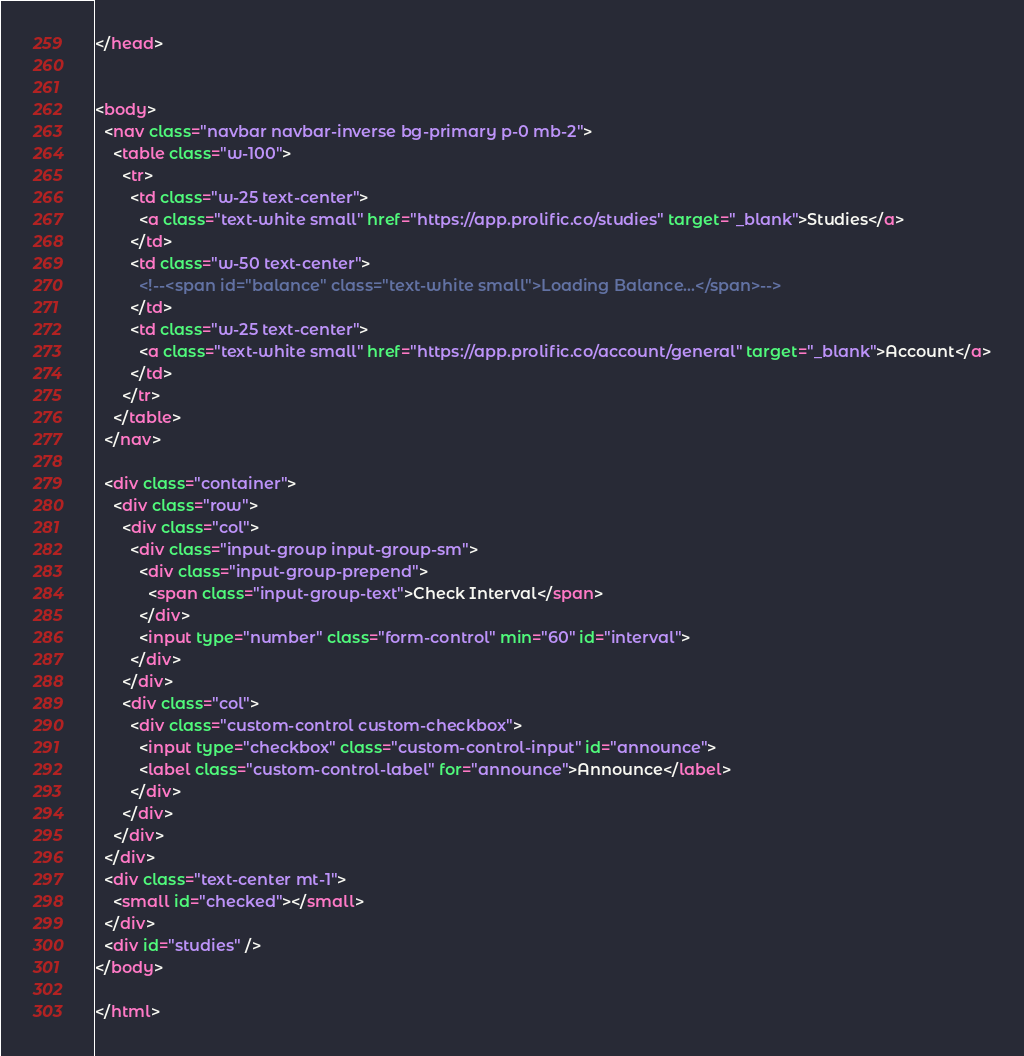<code> <loc_0><loc_0><loc_500><loc_500><_HTML_></head>


<body>
  <nav class="navbar navbar-inverse bg-primary p-0 mb-2">
    <table class="w-100">
      <tr>
        <td class="w-25 text-center">
          <a class="text-white small" href="https://app.prolific.co/studies" target="_blank">Studies</a>
        </td>
        <td class="w-50 text-center">
          <!--<span id="balance" class="text-white small">Loading Balance...</span>-->
        </td>
        <td class="w-25 text-center">
          <a class="text-white small" href="https://app.prolific.co/account/general" target="_blank">Account</a>
        </td>
      </tr>
    </table>
  </nav>

  <div class="container">
    <div class="row">
      <div class="col">
        <div class="input-group input-group-sm">
          <div class="input-group-prepend">
            <span class="input-group-text">Check Interval</span>
          </div>
          <input type="number" class="form-control" min="60" id="interval">
        </div>
      </div>
      <div class="col">
        <div class="custom-control custom-checkbox">
          <input type="checkbox" class="custom-control-input" id="announce">
          <label class="custom-control-label" for="announce">Announce</label>
        </div>
      </div>
    </div>
  </div>
  <div class="text-center mt-1">
    <small id="checked"></small>
  </div>
  <div id="studies" />
</body>

</html>
</code> 